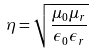Convert formula to latex. <formula><loc_0><loc_0><loc_500><loc_500>\eta = \sqrt { \frac { \mu _ { 0 } \mu _ { r } } { \epsilon _ { 0 } \epsilon _ { r } } }</formula> 